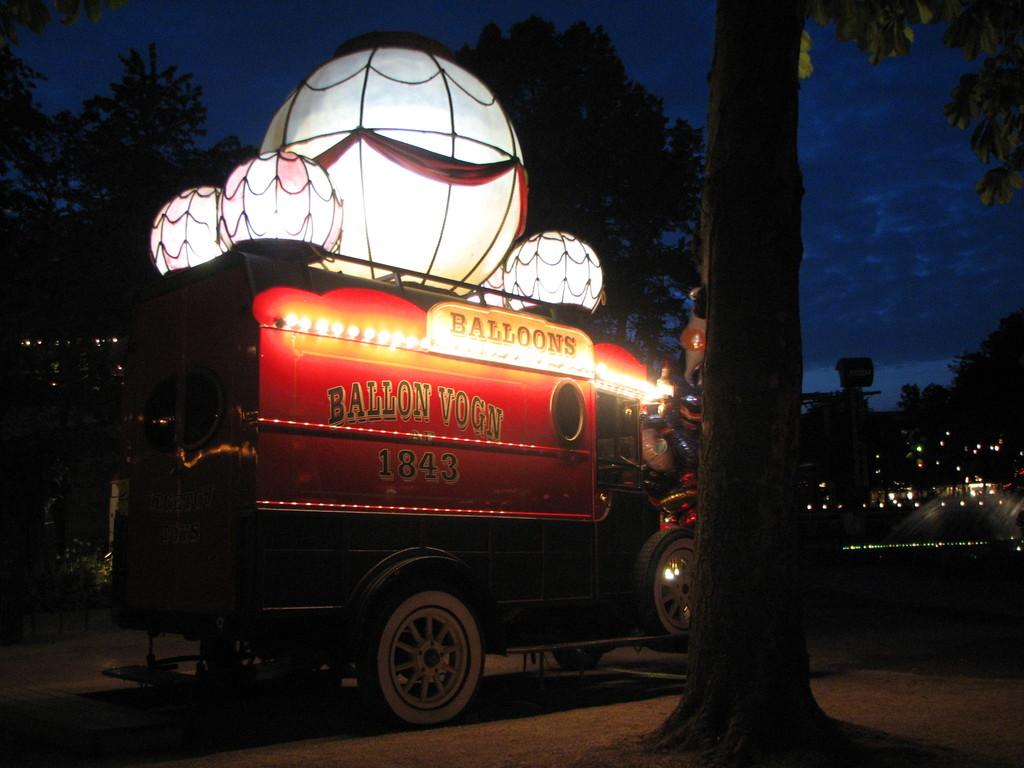What is on the road in the image? There is a vehicle on the road in the image. What is on top of the vehicle? There are balloons on top of the vehicle. What is located beside the vehicle? There is a tree beside the vehicle. What type of basket can be seen hanging from the tree in the image? There is no basket hanging from the tree in the image; only the vehicle and balloons are present. 